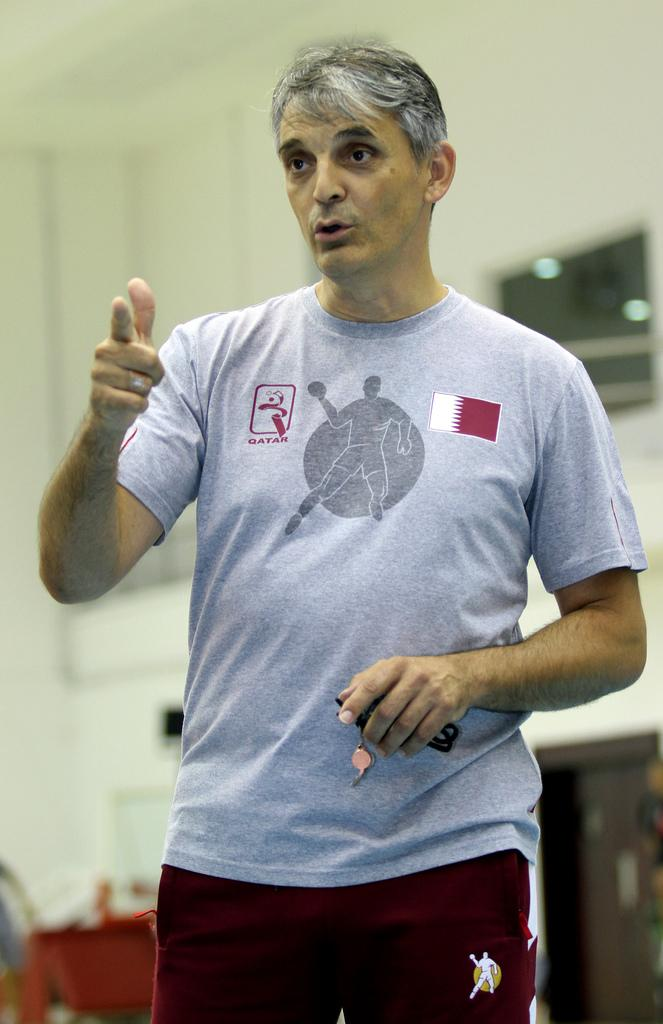Who is present in the image? There is a person in the image. Where is the person located? The person is standing in a room. What is the person holding in their hand? The person is holding keys in their hand. What can be seen behind the person? There is a wall visible in the image. What type of pollution can be seen in the image? There is no pollution visible in the image. What scientific theory is being demonstrated in the image? There is no scientific theory being demonstrated in the image. 